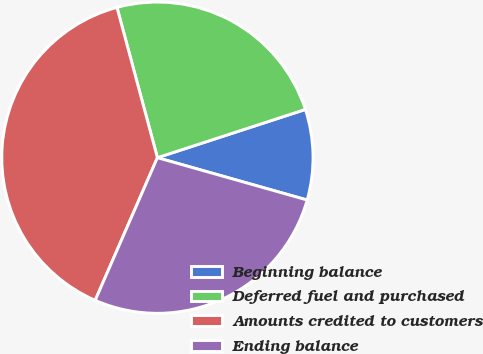Convert chart. <chart><loc_0><loc_0><loc_500><loc_500><pie_chart><fcel>Beginning balance<fcel>Deferred fuel and purchased<fcel>Amounts credited to customers<fcel>Ending balance<nl><fcel>9.4%<fcel>24.17%<fcel>39.27%<fcel>27.16%<nl></chart> 